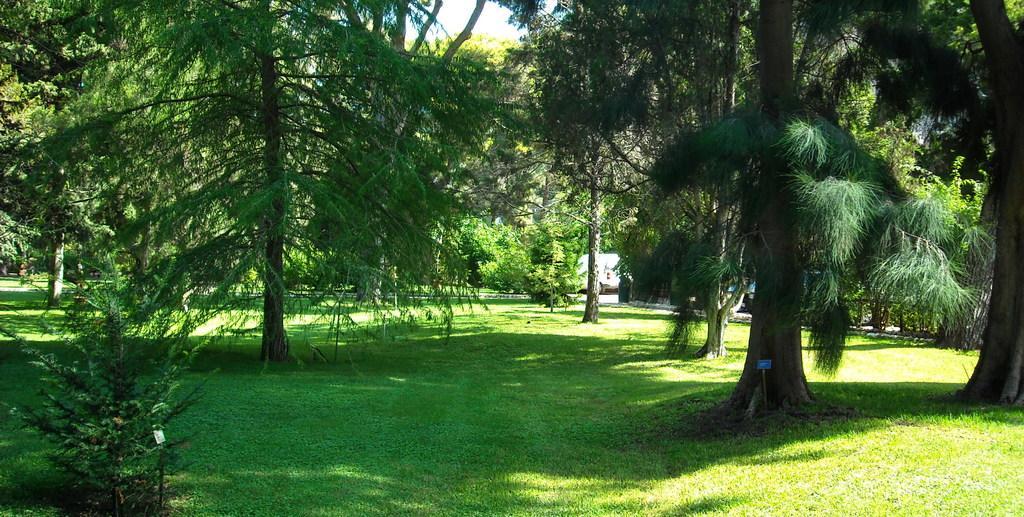Describe this image in one or two sentences. In this picture we can see the park. In the background there is a white car which is parked near to the wooden fencing. On the right we can see many trees. At the bottom we can see plants and grass. At the top we can see sky and clouds. 